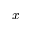Convert formula to latex. <formula><loc_0><loc_0><loc_500><loc_500>\bar { x }</formula> 